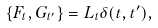<formula> <loc_0><loc_0><loc_500><loc_500>\{ F _ { t } , G _ { t ^ { \prime } } \} = L _ { t } \delta ( t , t ^ { \prime } ) ,</formula> 